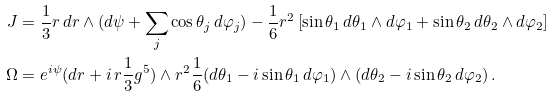Convert formula to latex. <formula><loc_0><loc_0><loc_500><loc_500>J & = \frac { 1 } { 3 } r \, d r \wedge ( d \psi + { \sum _ { j } \cos \theta _ { j } \, d \varphi _ { j } } ) - \frac { 1 } { 6 } r ^ { 2 } \left [ \sin \theta _ { 1 } \, d \theta _ { 1 } \wedge d \varphi _ { 1 } + \sin \theta _ { 2 } \, d \theta _ { 2 } \wedge d \varphi _ { 2 } \right ] \\ \Omega & = e ^ { i \psi } ( d r + i \, r \frac { 1 } { 3 } g ^ { 5 } ) \wedge r ^ { 2 } \frac { 1 } { 6 } ( d \theta _ { 1 } - i \sin \theta _ { 1 } \, d \varphi _ { 1 } ) \wedge ( d \theta _ { 2 } - i \sin \theta _ { 2 } \, d \varphi _ { 2 } ) \, .</formula> 